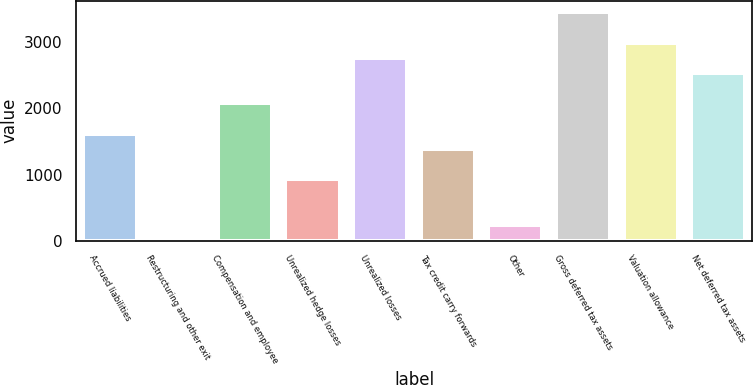Convert chart. <chart><loc_0><loc_0><loc_500><loc_500><bar_chart><fcel>Accrued liabilities<fcel>Restructuring and other exit<fcel>Compensation and employee<fcel>Unrealized hedge losses<fcel>Unrealized losses<fcel>Tax credit carry forwards<fcel>Other<fcel>Gross deferred tax assets<fcel>Valuation allowance<fcel>Net deferred tax assets<nl><fcel>1617.7<fcel>7<fcel>2077.9<fcel>927.4<fcel>2768.2<fcel>1387.6<fcel>237.1<fcel>3458.5<fcel>2998.3<fcel>2538.1<nl></chart> 